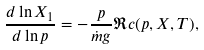Convert formula to latex. <formula><loc_0><loc_0><loc_500><loc_500>\frac { d \ln X _ { 1 } } { d \ln p } = - \frac { p } { \dot { m } g } \Re c ( p , X , T ) ,</formula> 